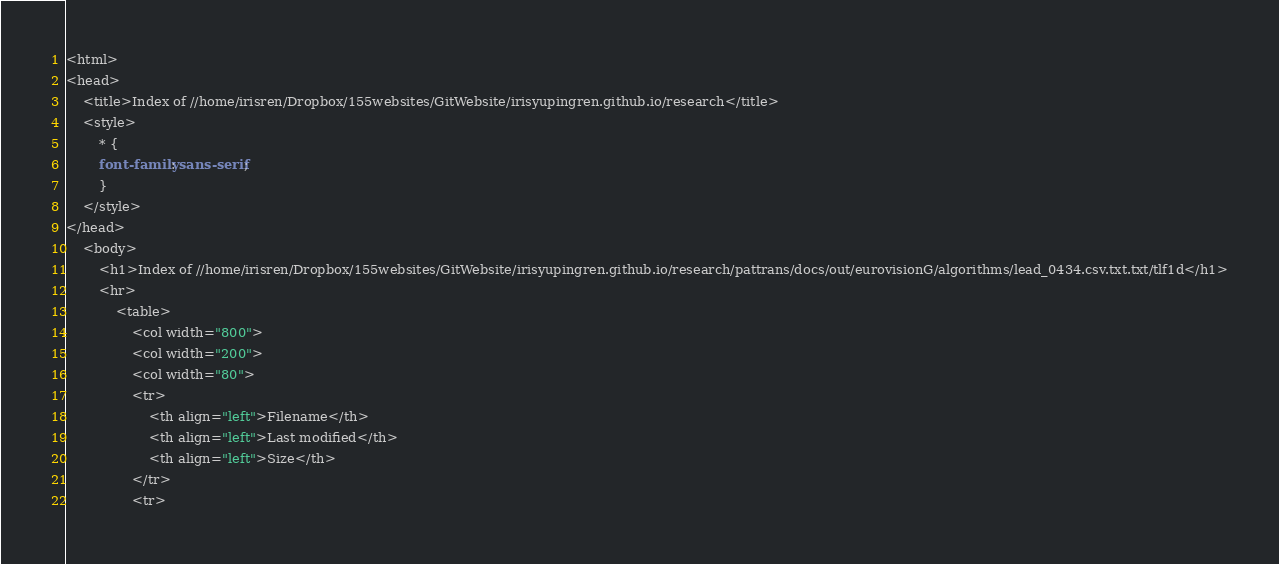Convert code to text. <code><loc_0><loc_0><loc_500><loc_500><_HTML_><html>
<head>
    <title>Index of //home/irisren/Dropbox/155websites/GitWebsite/irisyupingren.github.io/research</title>
    <style>
        * {
        font-family: sans-serif;
        }
    </style>
</head>
    <body>
        <h1>Index of //home/irisren/Dropbox/155websites/GitWebsite/irisyupingren.github.io/research/pattrans/docs/out/eurovisionG/algorithms/lead_0434.csv.txt.txt/tlf1d</h1>
        <hr>
            <table>
                <col width="800">
                <col width="200">
                <col width="80">
                <tr>
                    <th align="left">Filename</th>
                    <th align="left">Last modified</th>
                    <th align="left">Size</th>
                </tr>
                <tr></code> 